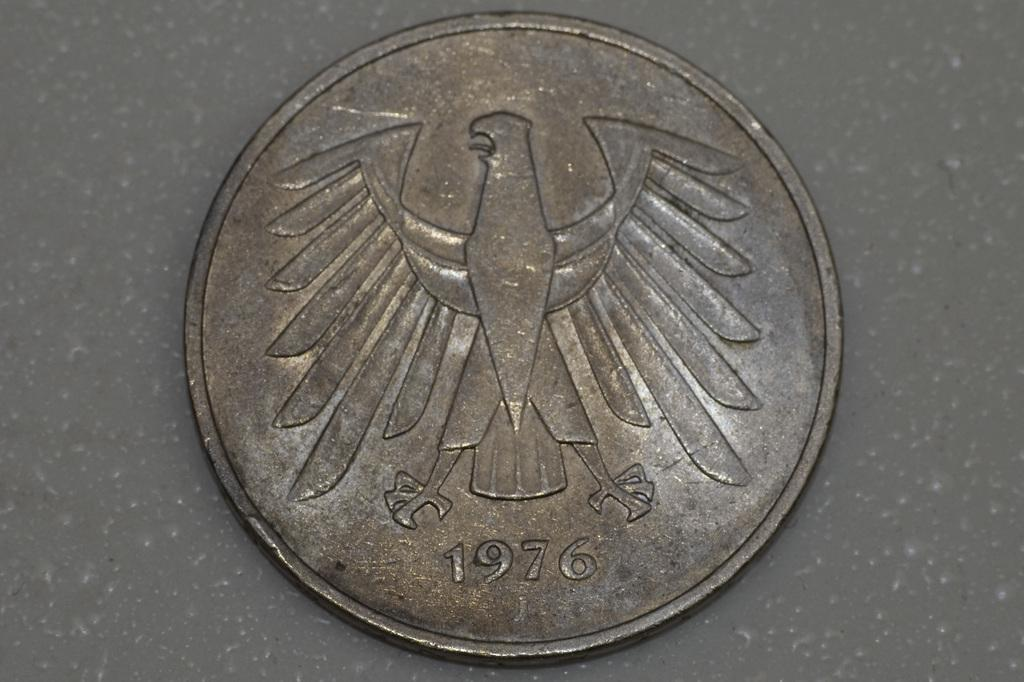<image>
Write a terse but informative summary of the picture. A dirty coin with a bird on it has 1976 engraved in it. 